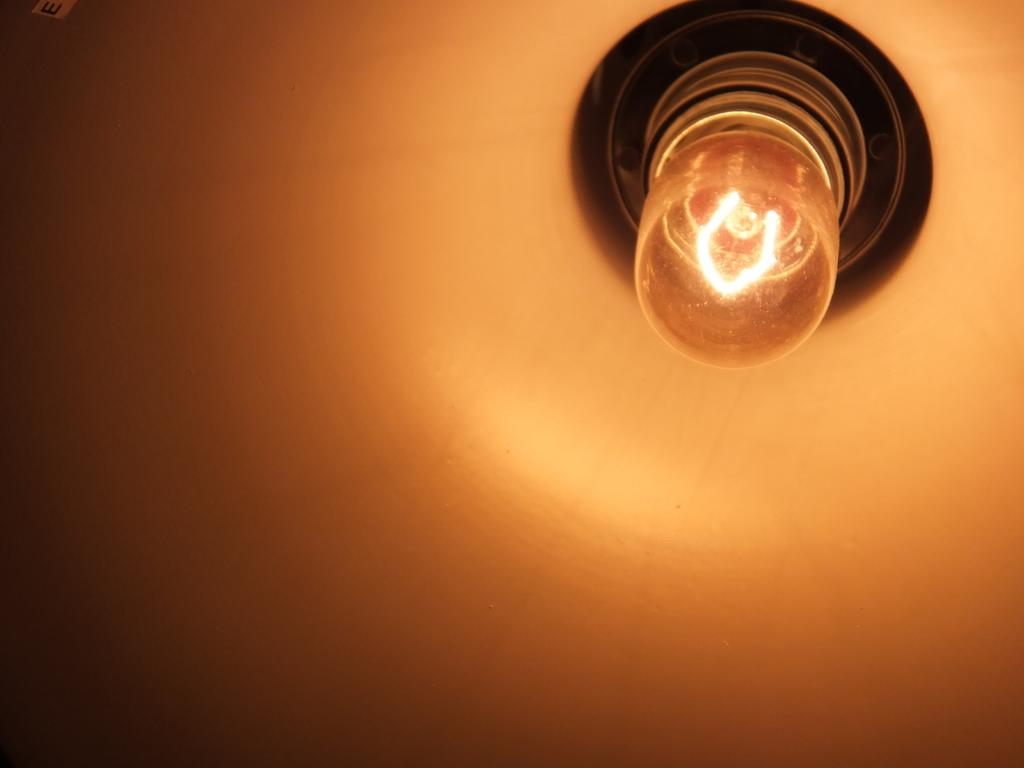What can be seen in the image that provides illumination? There is a light in the image. How many giants are wearing a cap in the image? There are no giants or caps present in the image; it only features a light. What achievement is the light celebrating in the image? The light is not an achiever, and there is no indication of any achievement being celebrated in the image. 